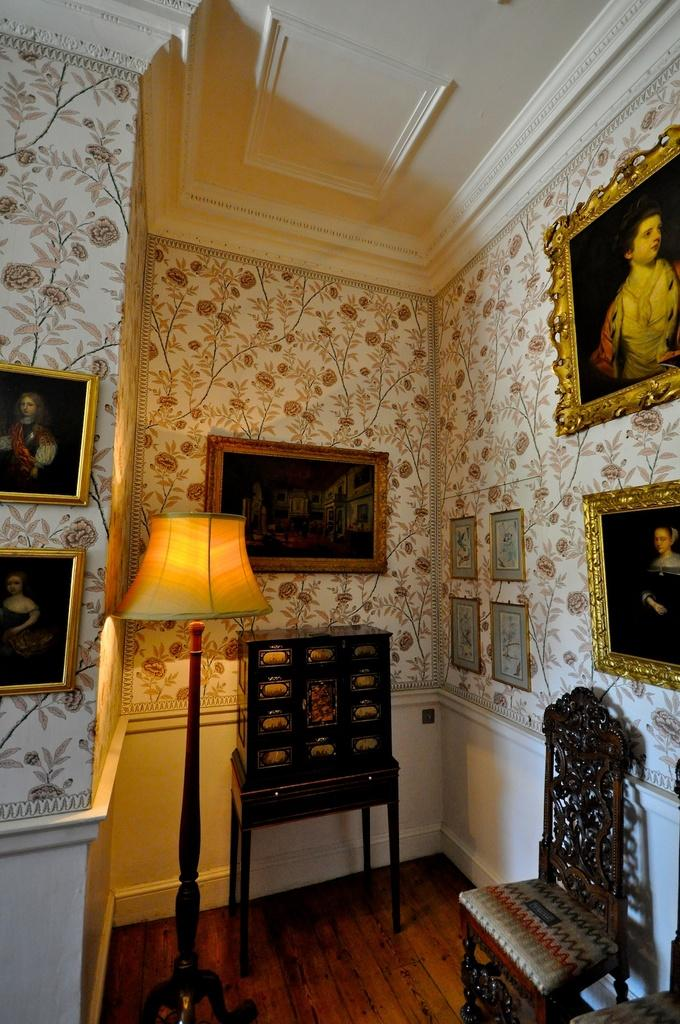What type of object can be seen providing light in the image? There is a lamp in the image. What type of storage unit is visible in the image? There is a locker in the image. What type of furniture is present for sitting in the image? There is a chair in the image. What type of decoration can be seen on the wall in the background of the image? There is a photo frame attached to the wall in the background of the image. Can you see any honey dripping from the lamp in the image? There is no honey present in the image, and the lamp is not shown dripping anything. 